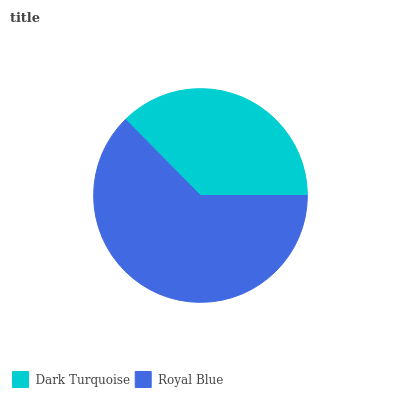Is Dark Turquoise the minimum?
Answer yes or no. Yes. Is Royal Blue the maximum?
Answer yes or no. Yes. Is Royal Blue the minimum?
Answer yes or no. No. Is Royal Blue greater than Dark Turquoise?
Answer yes or no. Yes. Is Dark Turquoise less than Royal Blue?
Answer yes or no. Yes. Is Dark Turquoise greater than Royal Blue?
Answer yes or no. No. Is Royal Blue less than Dark Turquoise?
Answer yes or no. No. Is Royal Blue the high median?
Answer yes or no. Yes. Is Dark Turquoise the low median?
Answer yes or no. Yes. Is Dark Turquoise the high median?
Answer yes or no. No. Is Royal Blue the low median?
Answer yes or no. No. 